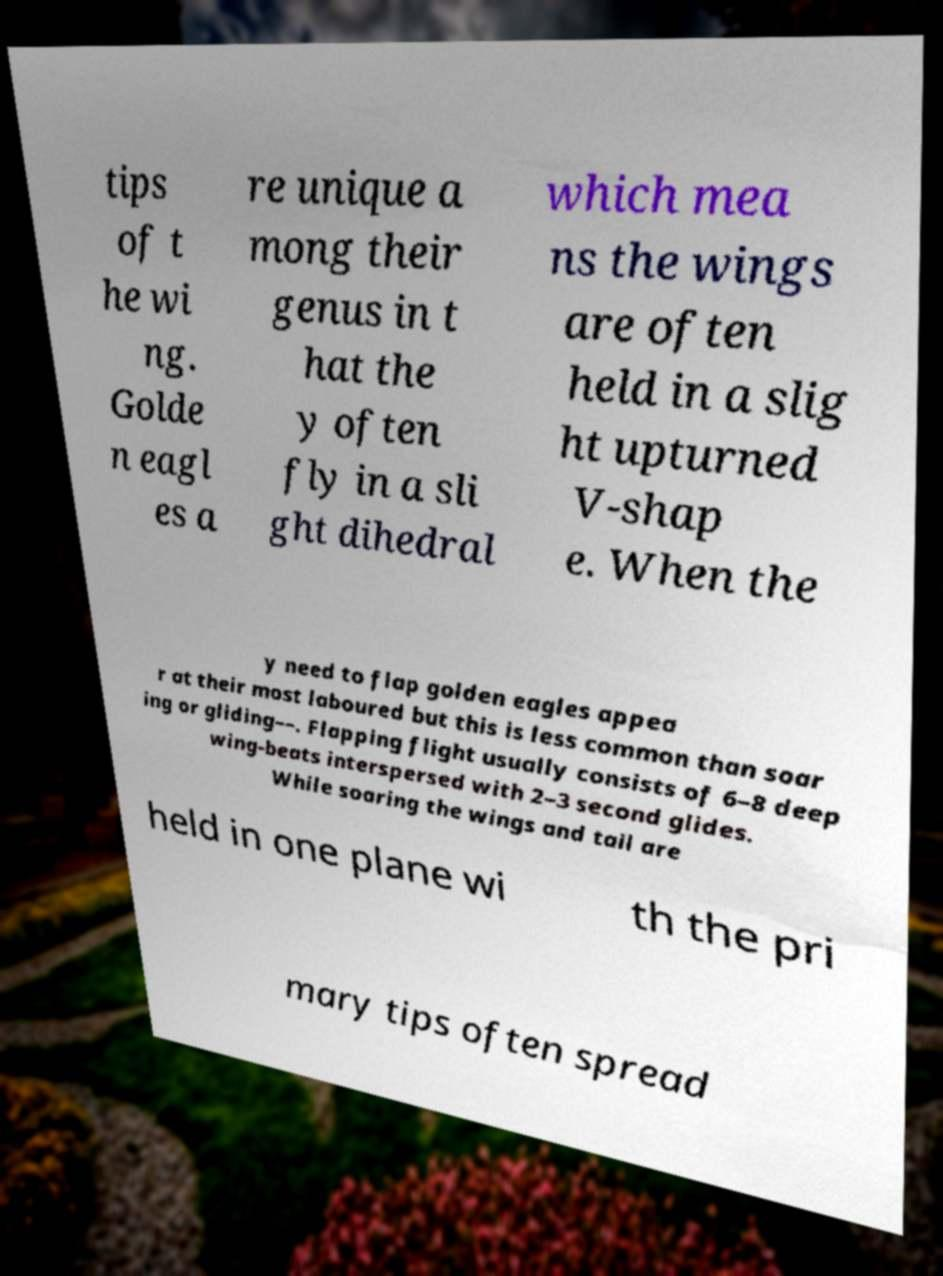Please identify and transcribe the text found in this image. tips of t he wi ng. Golde n eagl es a re unique a mong their genus in t hat the y often fly in a sli ght dihedral which mea ns the wings are often held in a slig ht upturned V-shap e. When the y need to flap golden eagles appea r at their most laboured but this is less common than soar ing or gliding––. Flapping flight usually consists of 6–8 deep wing-beats interspersed with 2–3 second glides. While soaring the wings and tail are held in one plane wi th the pri mary tips often spread 